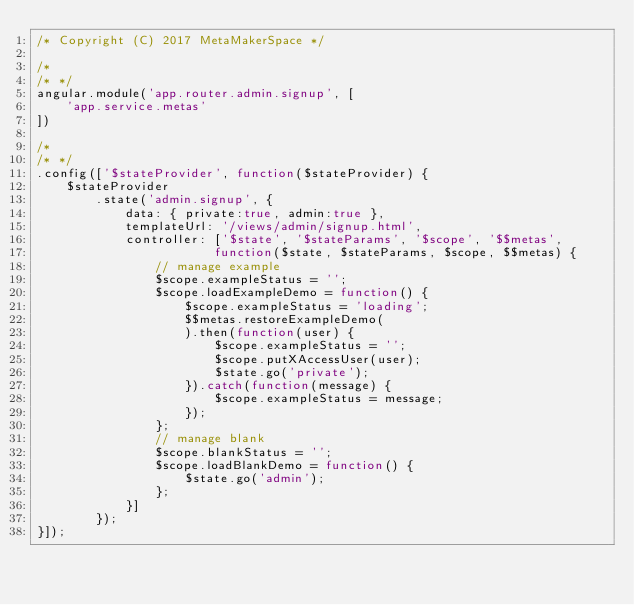<code> <loc_0><loc_0><loc_500><loc_500><_JavaScript_>/* Copyright (C) 2017 MetaMakerSpace */

/*
/* */
angular.module('app.router.admin.signup', [
    'app.service.metas'
])

/*
/* */
.config(['$stateProvider', function($stateProvider) {
    $stateProvider
        .state('admin.signup', {
            data: { private:true, admin:true },
            templateUrl: '/views/admin/signup.html',
            controller: ['$state', '$stateParams', '$scope', '$$metas',
                        function($state, $stateParams, $scope, $$metas) {
                // manage example
                $scope.exampleStatus = '';
                $scope.loadExampleDemo = function() {
                    $scope.exampleStatus = 'loading';
                    $$metas.restoreExampleDemo(
                    ).then(function(user) {
                        $scope.exampleStatus = '';
                        $scope.putXAccessUser(user);
                        $state.go('private');
                    }).catch(function(message) {
                        $scope.exampleStatus = message;
                    });
                };
                // manage blank
                $scope.blankStatus = '';
                $scope.loadBlankDemo = function() {
                    $state.go('admin');
                };
            }]
        });
}]);
</code> 